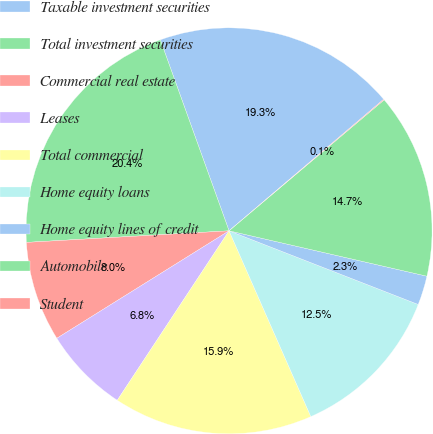<chart> <loc_0><loc_0><loc_500><loc_500><pie_chart><fcel>Taxable investment securities<fcel>Total investment securities<fcel>Commercial real estate<fcel>Leases<fcel>Total commercial<fcel>Home equity loans<fcel>Home equity lines of credit<fcel>Automobile<fcel>Student<nl><fcel>19.28%<fcel>20.41%<fcel>7.97%<fcel>6.84%<fcel>15.88%<fcel>12.49%<fcel>2.32%<fcel>14.75%<fcel>0.06%<nl></chart> 